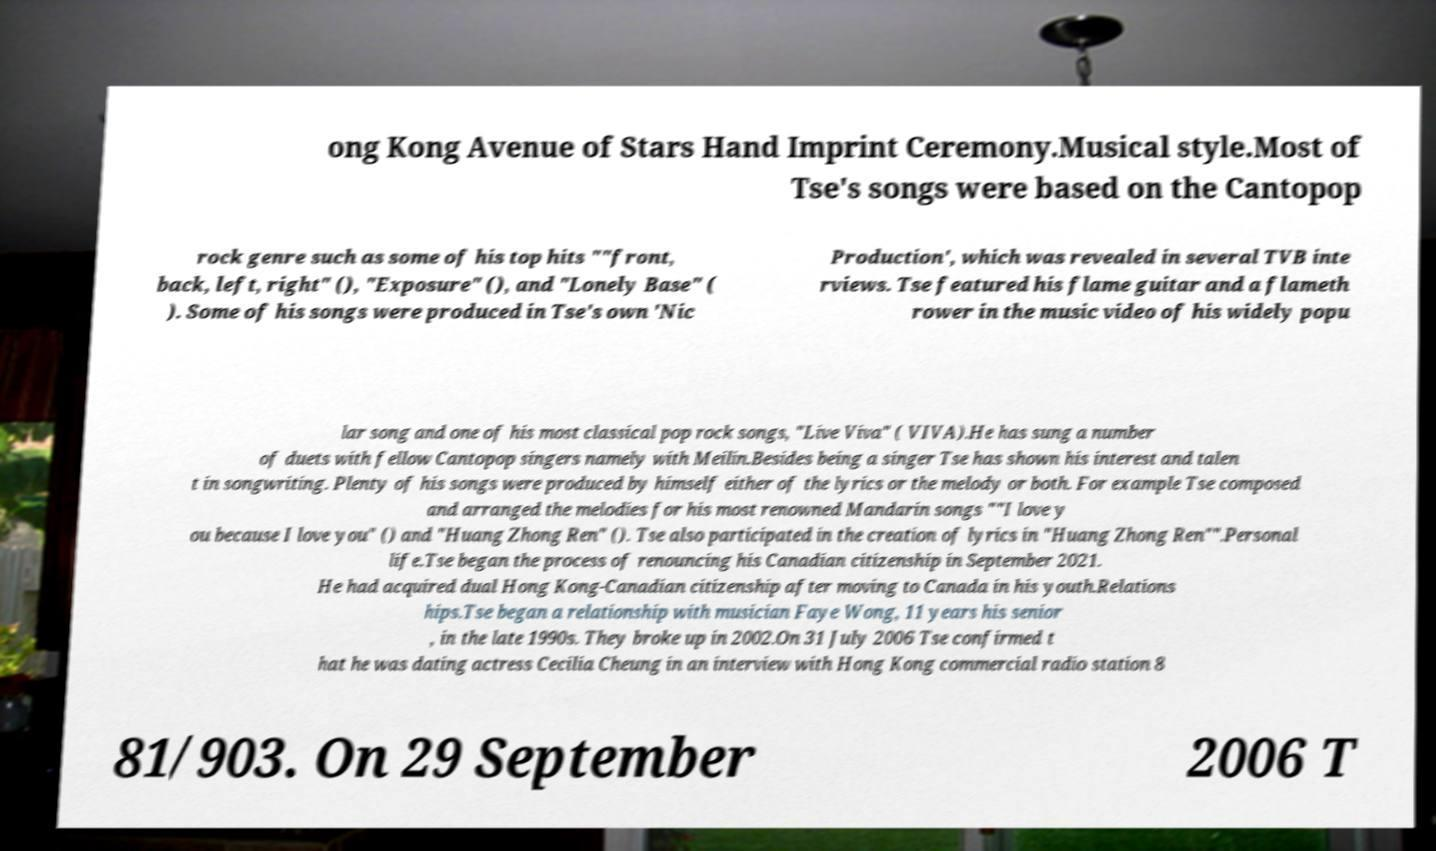Could you extract and type out the text from this image? ong Kong Avenue of Stars Hand Imprint Ceremony.Musical style.Most of Tse's songs were based on the Cantopop rock genre such as some of his top hits ""front, back, left, right" (), "Exposure" (), and "Lonely Base" ( ). Some of his songs were produced in Tse's own 'Nic Production', which was revealed in several TVB inte rviews. Tse featured his flame guitar and a flameth rower in the music video of his widely popu lar song and one of his most classical pop rock songs, "Live Viva" ( VIVA).He has sung a number of duets with fellow Cantopop singers namely with Meilin.Besides being a singer Tse has shown his interest and talen t in songwriting. Plenty of his songs were produced by himself either of the lyrics or the melody or both. For example Tse composed and arranged the melodies for his most renowned Mandarin songs ""I love y ou because I love you" () and "Huang Zhong Ren" (). Tse also participated in the creation of lyrics in "Huang Zhong Ren"".Personal life.Tse began the process of renouncing his Canadian citizenship in September 2021. He had acquired dual Hong Kong-Canadian citizenship after moving to Canada in his youth.Relations hips.Tse began a relationship with musician Faye Wong, 11 years his senior , in the late 1990s. They broke up in 2002.On 31 July 2006 Tse confirmed t hat he was dating actress Cecilia Cheung in an interview with Hong Kong commercial radio station 8 81/903. On 29 September 2006 T 